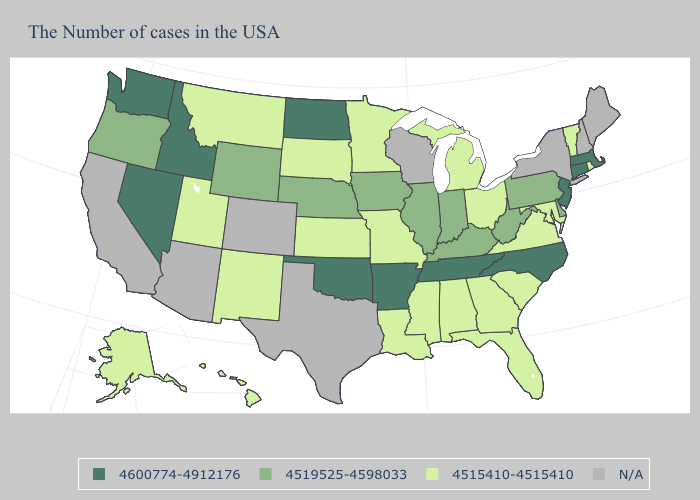Name the states that have a value in the range N/A?
Answer briefly. Maine, New Hampshire, New York, Wisconsin, Texas, Colorado, Arizona, California. Name the states that have a value in the range 4519525-4598033?
Quick response, please. Delaware, Pennsylvania, West Virginia, Kentucky, Indiana, Illinois, Iowa, Nebraska, Wyoming, Oregon. Does North Dakota have the highest value in the USA?
Quick response, please. Yes. Does the map have missing data?
Short answer required. Yes. Name the states that have a value in the range 4515410-4515410?
Keep it brief. Rhode Island, Vermont, Maryland, Virginia, South Carolina, Ohio, Florida, Georgia, Michigan, Alabama, Mississippi, Louisiana, Missouri, Minnesota, Kansas, South Dakota, New Mexico, Utah, Montana, Alaska, Hawaii. Name the states that have a value in the range N/A?
Keep it brief. Maine, New Hampshire, New York, Wisconsin, Texas, Colorado, Arizona, California. Name the states that have a value in the range N/A?
Give a very brief answer. Maine, New Hampshire, New York, Wisconsin, Texas, Colorado, Arizona, California. What is the value of Indiana?
Keep it brief. 4519525-4598033. What is the value of North Dakota?
Answer briefly. 4600774-4912176. What is the highest value in the USA?
Give a very brief answer. 4600774-4912176. Does South Carolina have the highest value in the South?
Concise answer only. No. What is the highest value in the USA?
Answer briefly. 4600774-4912176. Which states have the lowest value in the USA?
Quick response, please. Rhode Island, Vermont, Maryland, Virginia, South Carolina, Ohio, Florida, Georgia, Michigan, Alabama, Mississippi, Louisiana, Missouri, Minnesota, Kansas, South Dakota, New Mexico, Utah, Montana, Alaska, Hawaii. Name the states that have a value in the range 4600774-4912176?
Write a very short answer. Massachusetts, Connecticut, New Jersey, North Carolina, Tennessee, Arkansas, Oklahoma, North Dakota, Idaho, Nevada, Washington. How many symbols are there in the legend?
Give a very brief answer. 4. 